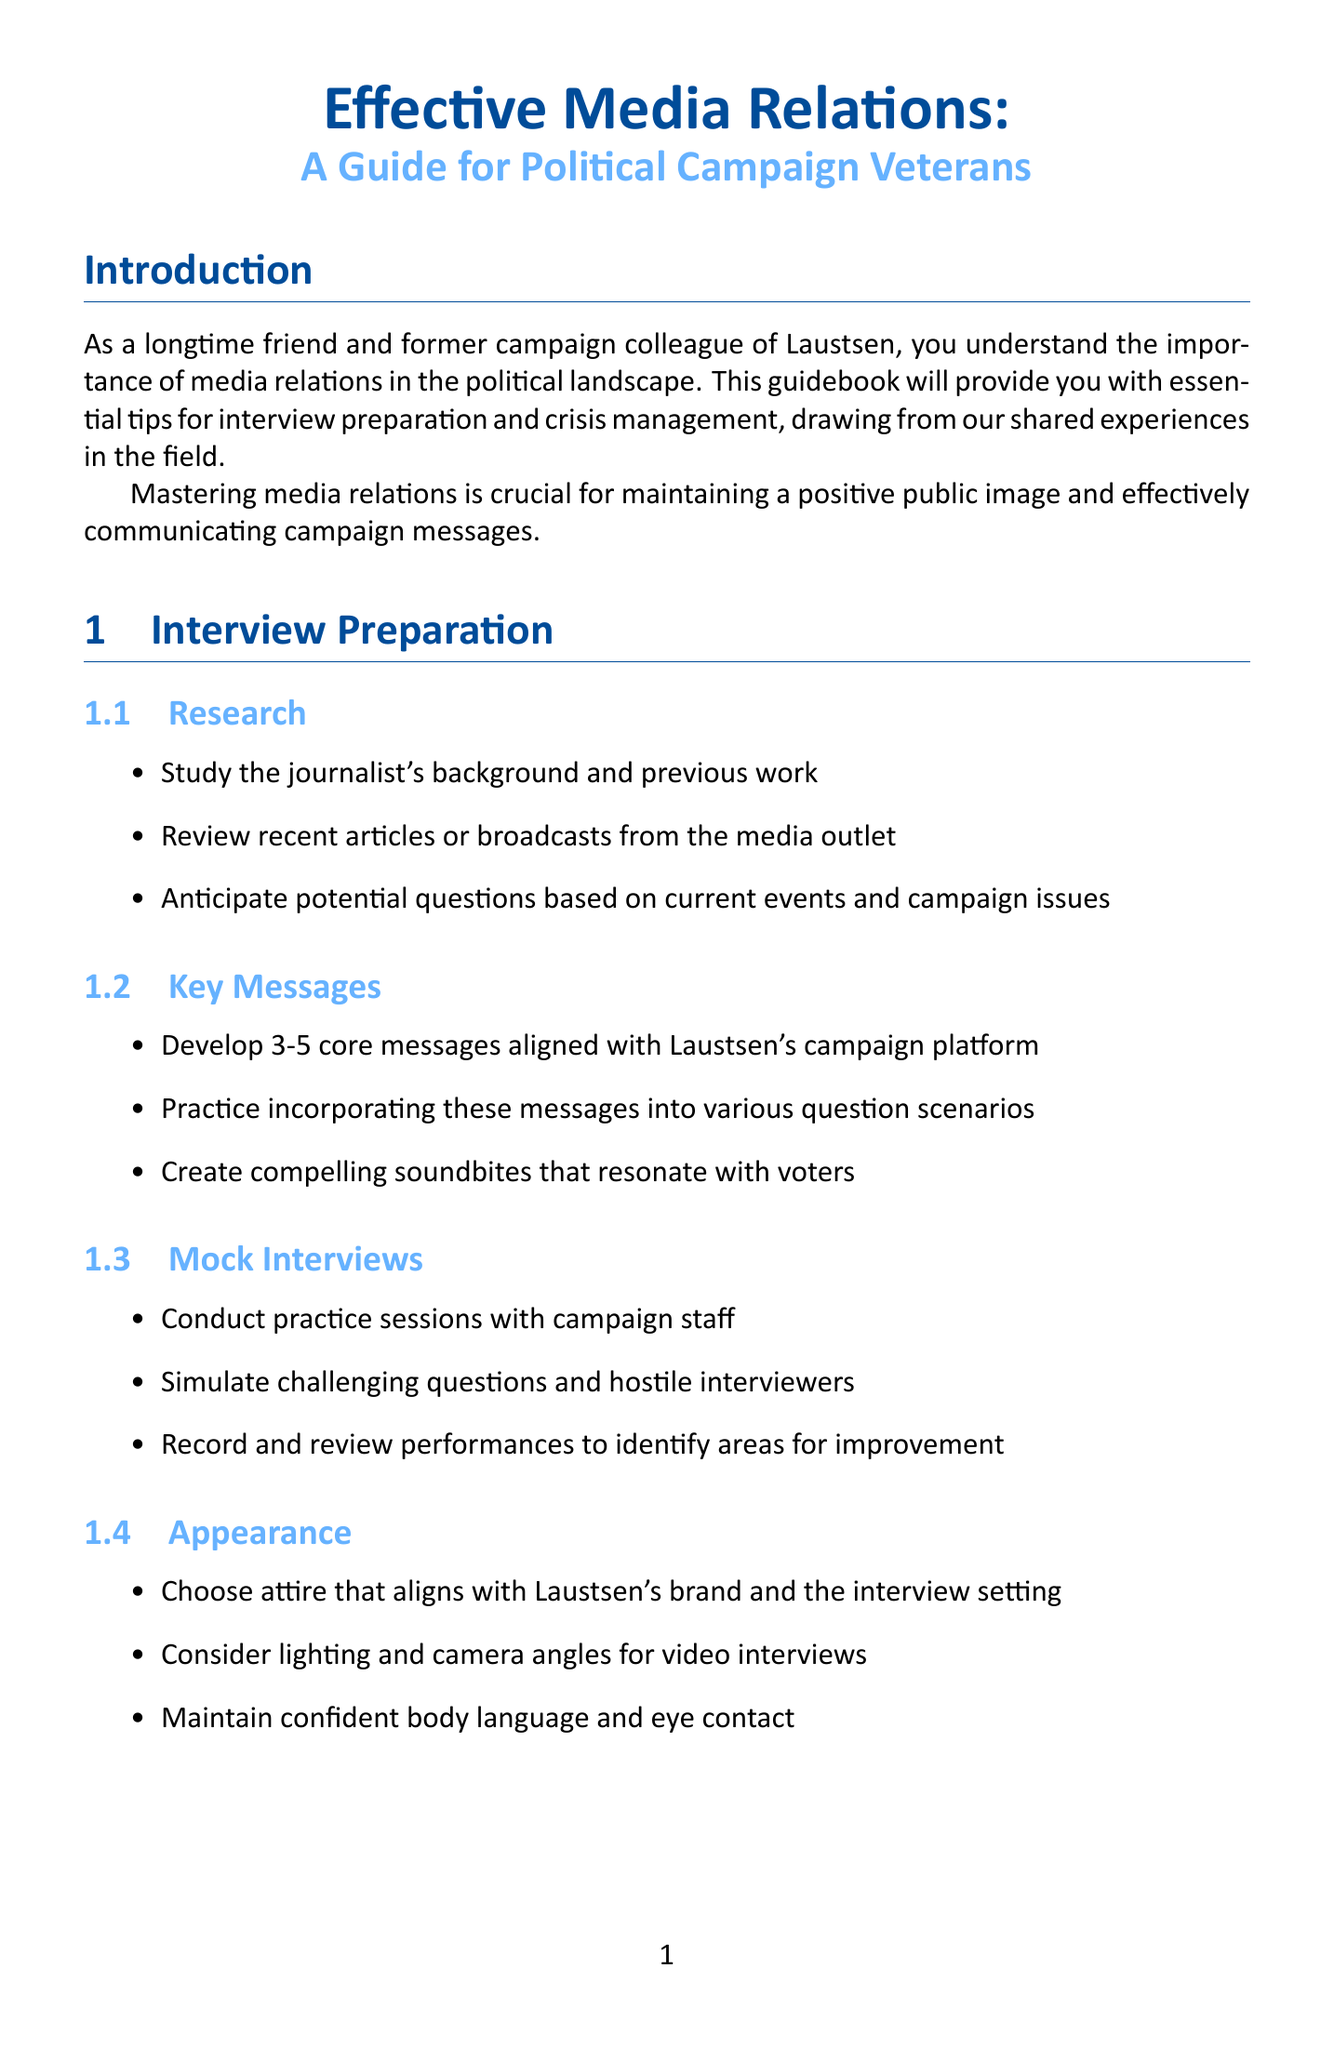what is the title of the manual? The title is specified at the beginning of the document as the main heading.
Answer: Effective Media Relations: A Guide for Political Campaign Veterans how many key messages should be developed for interview preparation? This information is explicitly mentioned in the section regarding key messages in interview preparation.
Answer: 3-5 what should be included in a crisis communication plan? The document provides specific information on what should be developed in advance as part of crisis preparedness.
Answer: Crisis communication plan who is recommended to be the single spokesperson in crisis situations? The document indicates who should be designated as the spokesperson in communication strategies under crisis management.
Answer: Laustsen which social media platform is mentioned for community building? This platform is noted in the section discussing social media and its uses in media relations.
Answer: Facebook what type of media relationships should be established during networking? The document provides guidance in the networking section about what kinds of events to attend for building relationships.
Answer: Industry events how often should media relationships be maintained? The document specifies the nature of the process for relationships in the conclusion section.
Answer: Ongoing what is a recommended strategy for addressing misinformation? The document particularly discusses a specific approach during the media engagement subsection.
Answer: Correct misinformation promptly and respectfully 